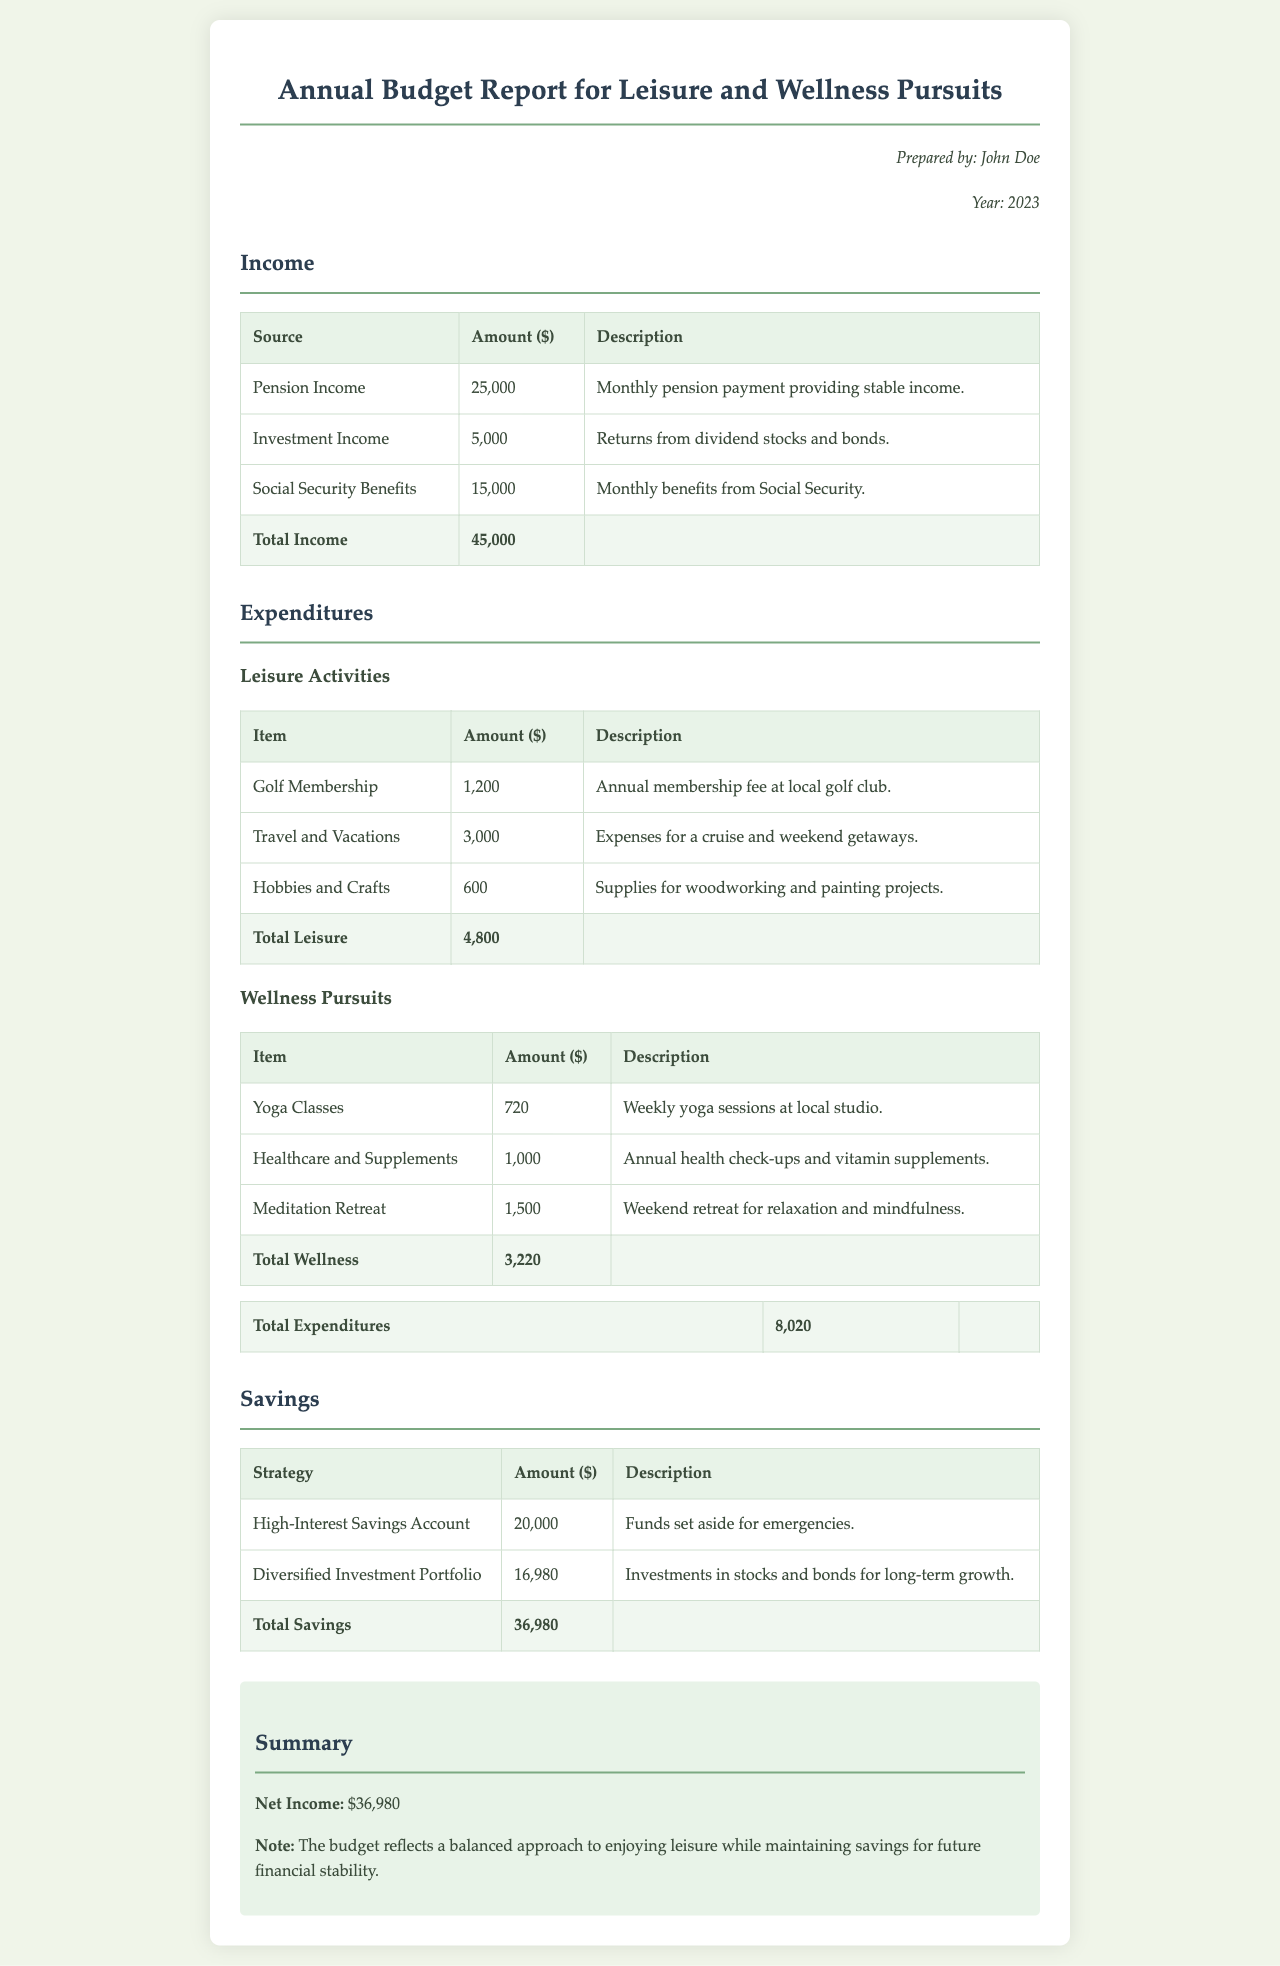What is the total income? The total income is calculated based on all income sources listed in the document: $25,000 + $5,000 + $15,000 = $45,000.
Answer: $45,000 What was spent on travel and vacations? The amount spent on travel and vacations is listed under leisure activities in the expenditures section, which is $3,000.
Answer: $3,000 How much was allocated to yoga classes? The budget for yoga classes is detailed in the wellness pursuits table, which indicates an expenditure of $720.
Answer: $720 What is the total expenditure for leisure activities? The total expenditure for leisure activities is summed from the individual items, resulting in a total of $4,800.
Answer: $4,800 What is the total savings amount? The total savings is the sum of the amounts listed under the savings section, which is $20,000 + $16,980 = $36,980.
Answer: $36,980 What percentage of total income was spent on expenditures? To find this, calculate (Total Expenditures / Total Income) * 100, which is ($8,020 / $45,000) * 100 ≈ 17.8%.
Answer: 17.8% What category includes the meditation retreat? The meditation retreat is categorized under wellness pursuits in the expenditures section.
Answer: wellness pursuits Who prepared the report? The report mentions that it was prepared by John Doe, as indicated in the prepared by section.
Answer: John Doe What is the main focus of the budget in this report? The budget report specifically focuses on income, expenditures, and savings related to leisure activities and wellness pursuits.
Answer: leisure activities and wellness pursuits 